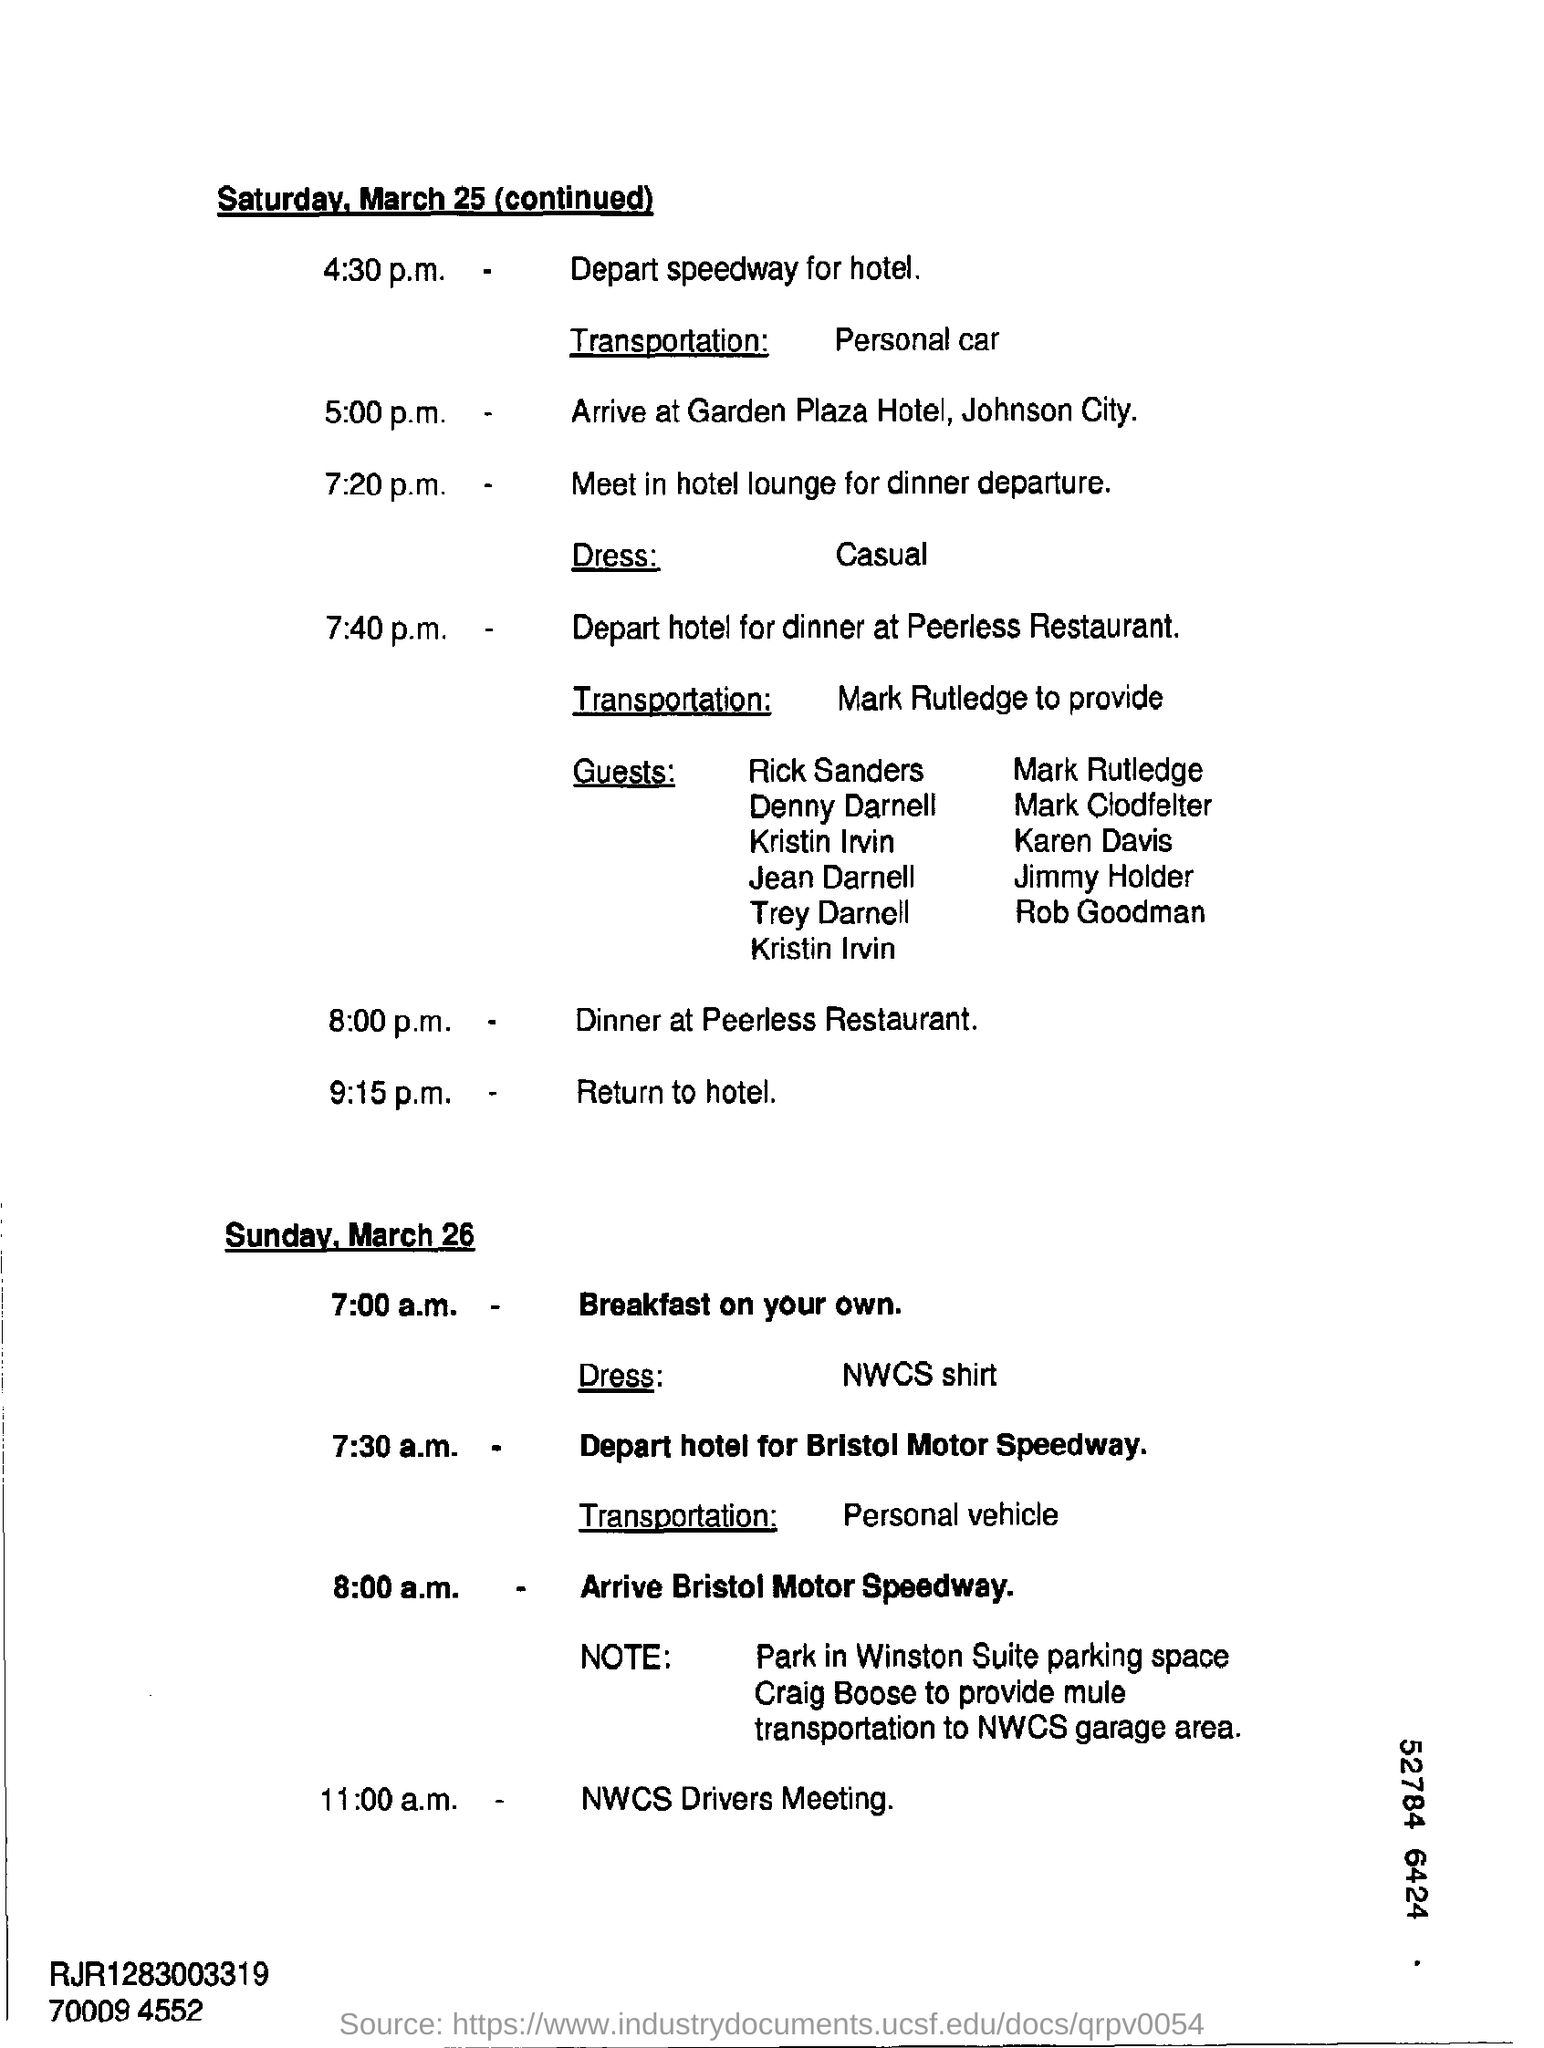What kind transportation is mentioned at saturday 4:30 p.m. ?
Your response must be concise. Personal car. What was the time to arrive at garden plaza hotel ?
Give a very brief answer. 5:00 p.m. What kind of dress was mentioned for dinner departure ?
Provide a short and direct response. Casual. Where is the dinner place at 8:00 p.m. ?
Your response must be concise. Peerless Restaurant. What is the meeting at 11:00 a.m. ?
Ensure brevity in your answer.  NWCS Drivers Meeting. 